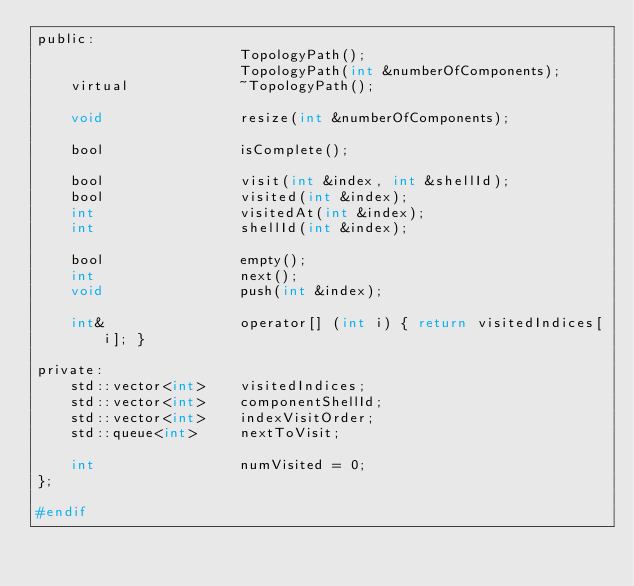<code> <loc_0><loc_0><loc_500><loc_500><_C_>public:
                        TopologyPath();
                        TopologyPath(int &numberOfComponents);
    virtual             ~TopologyPath();
    
    void                resize(int &numberOfComponents);
    
    bool                isComplete();

    bool                visit(int &index, int &shellId);
    bool                visited(int &index);
    int                 visitedAt(int &index);
    int                 shellId(int &index);

    bool                empty();
    int                 next();
    void                push(int &index);

    int&                operator[] (int i) { return visitedIndices[i]; }

private:
    std::vector<int>    visitedIndices;
    std::vector<int>    componentShellId;
    std::vector<int>    indexVisitOrder;
    std::queue<int>     nextToVisit;

    int                 numVisited = 0;
};

#endif</code> 